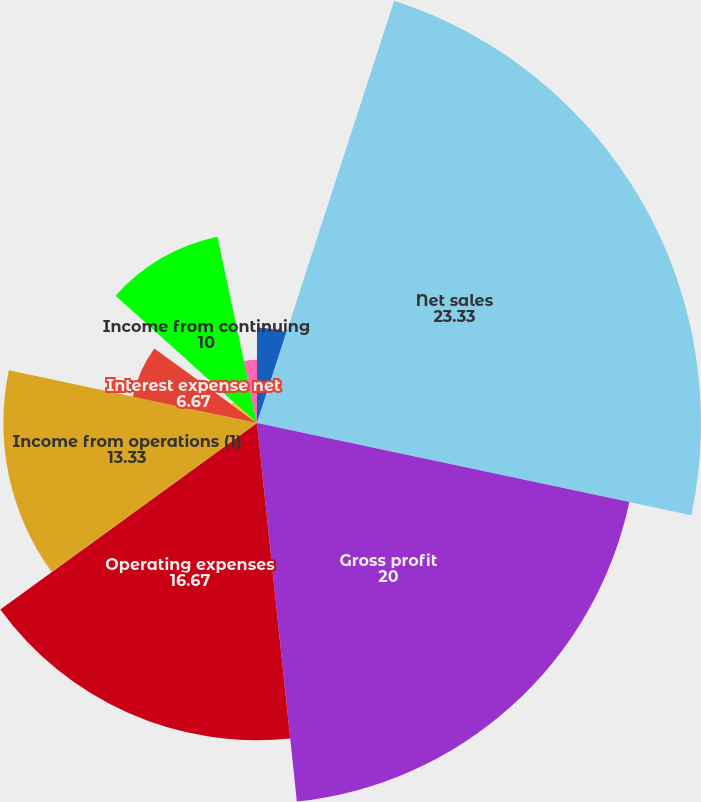<chart> <loc_0><loc_0><loc_500><loc_500><pie_chart><fcel>In thousands except per share<fcel>Net sales<fcel>Gross profit<fcel>Operating expenses<fcel>Income from operations (1)<fcel>Interest expense net<fcel>Other income (expense) net<fcel>Income from continuing<fcel>Net income attributable to<nl><fcel>5.0%<fcel>23.33%<fcel>20.0%<fcel>16.67%<fcel>13.33%<fcel>6.67%<fcel>1.67%<fcel>10.0%<fcel>3.33%<nl></chart> 